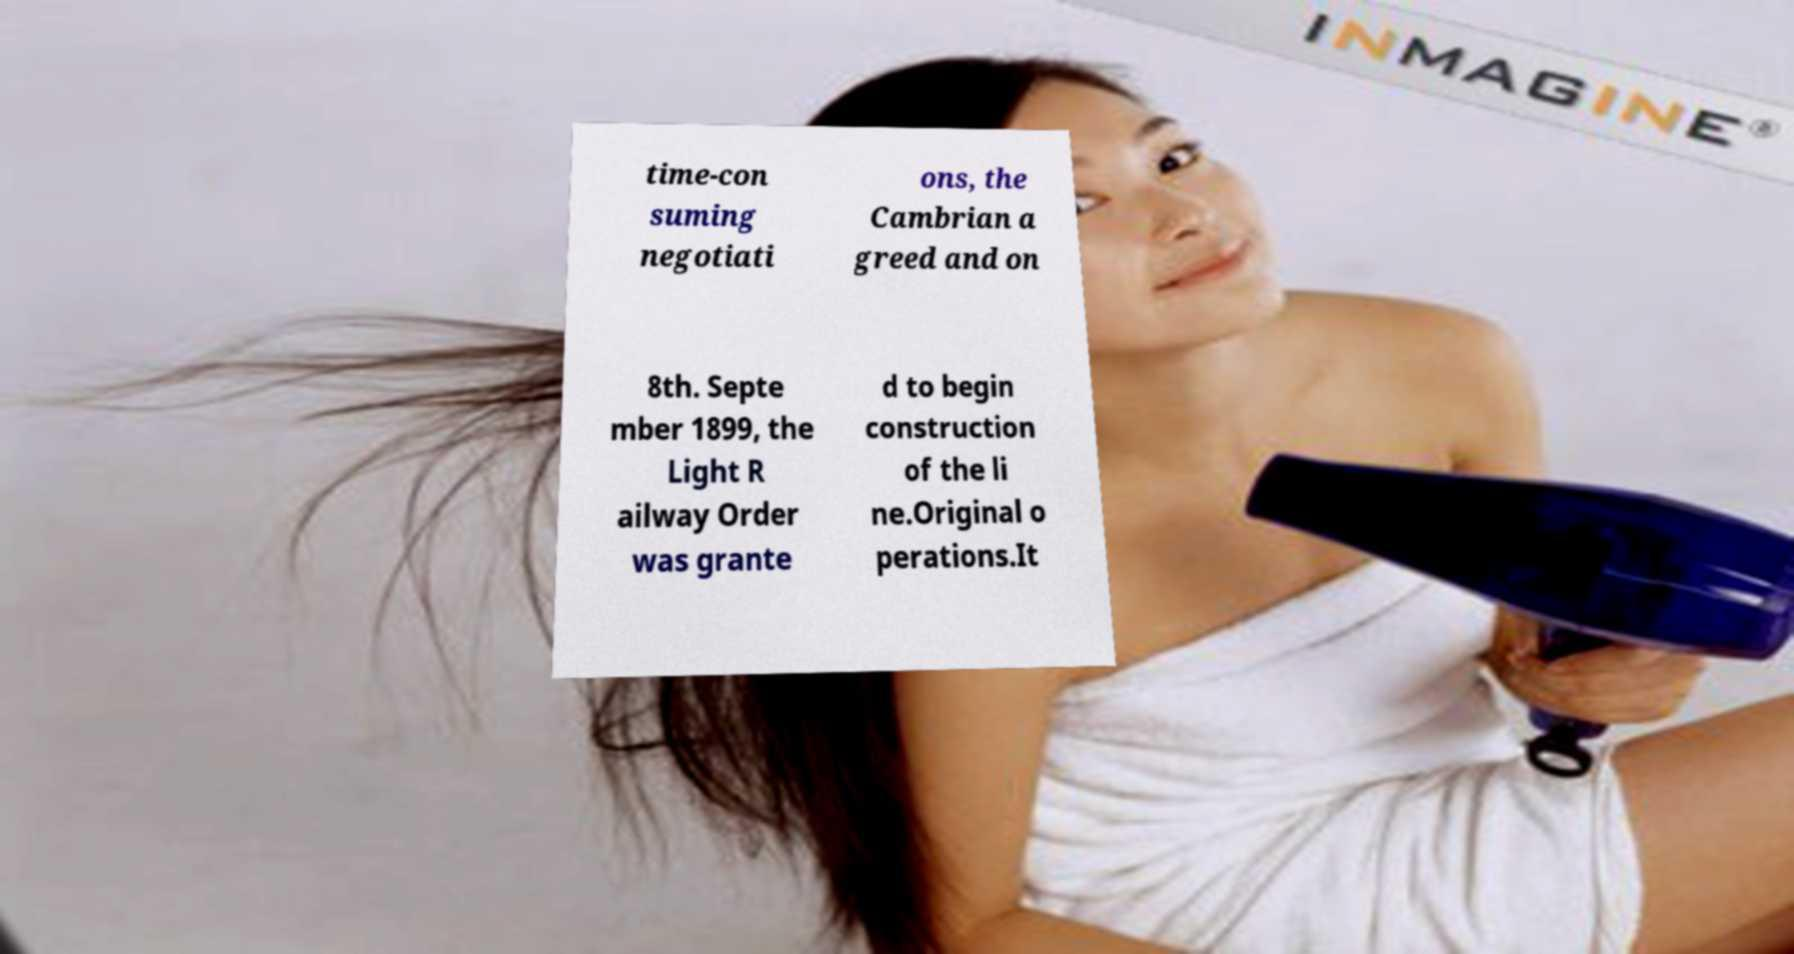For documentation purposes, I need the text within this image transcribed. Could you provide that? time-con suming negotiati ons, the Cambrian a greed and on 8th. Septe mber 1899, the Light R ailway Order was grante d to begin construction of the li ne.Original o perations.It 